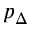Convert formula to latex. <formula><loc_0><loc_0><loc_500><loc_500>p _ { \Delta }</formula> 